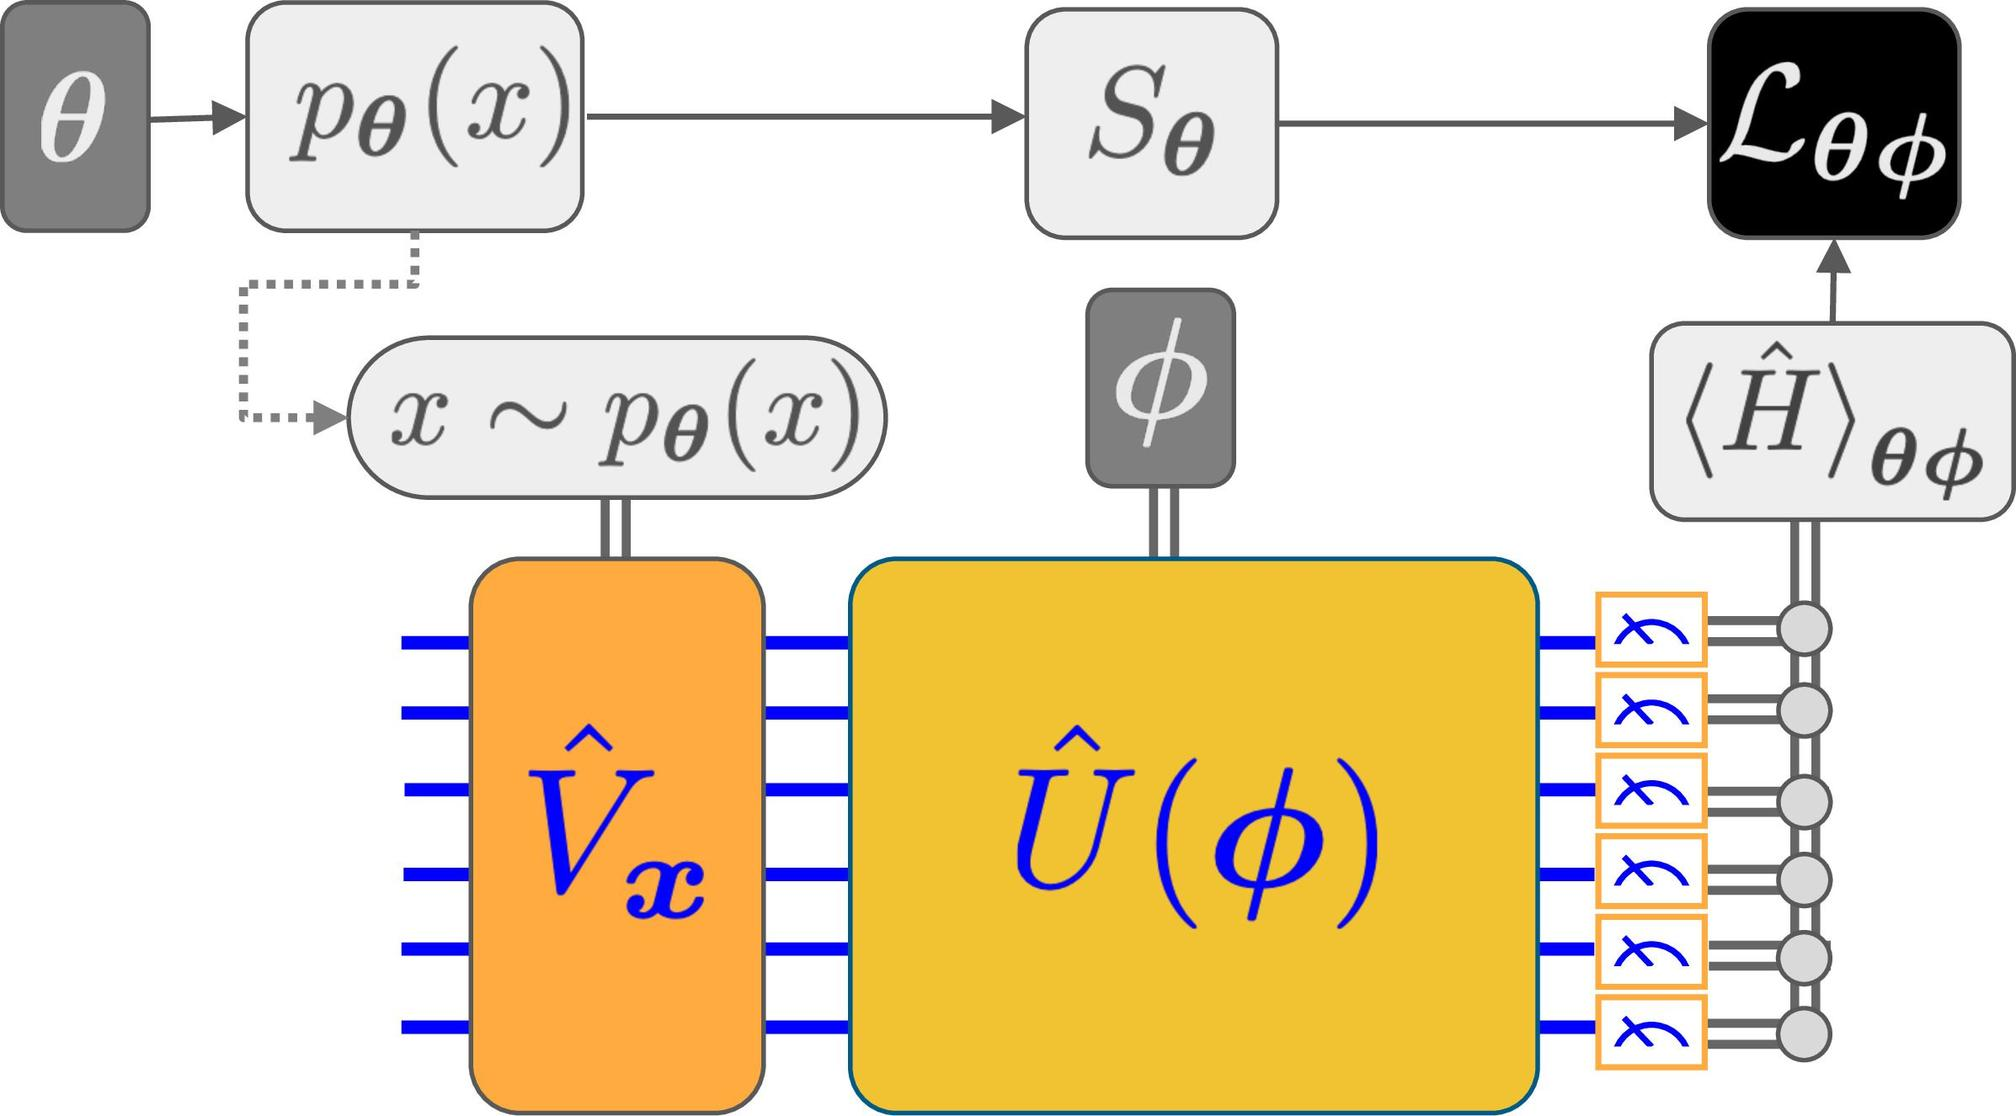What can be inferred about the role of \( S_{\theta} \) in the diagram? A. It selects a specific state based on the parameter \( \theta \). B. It represents the entropy of the system. C. It denotes a scattering matrix dependent on \( \theta \). D. It symbolizes a source of random sampling based on \( \theta \). \( S_{\theta} \) is connected to \( p_{\theta}(x) \), which suggests it plays a role in selecting or generating states based on the parameter \( \theta \). In such diagrams, a box with a parameter typically represents an operation or a selection process controlled by that parameter. Therefore, the correct answer is A. 